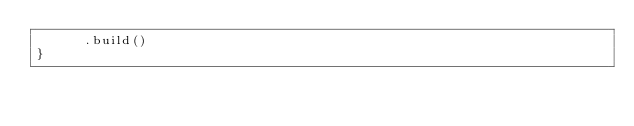<code> <loc_0><loc_0><loc_500><loc_500><_Scala_>      .build()
}
</code> 